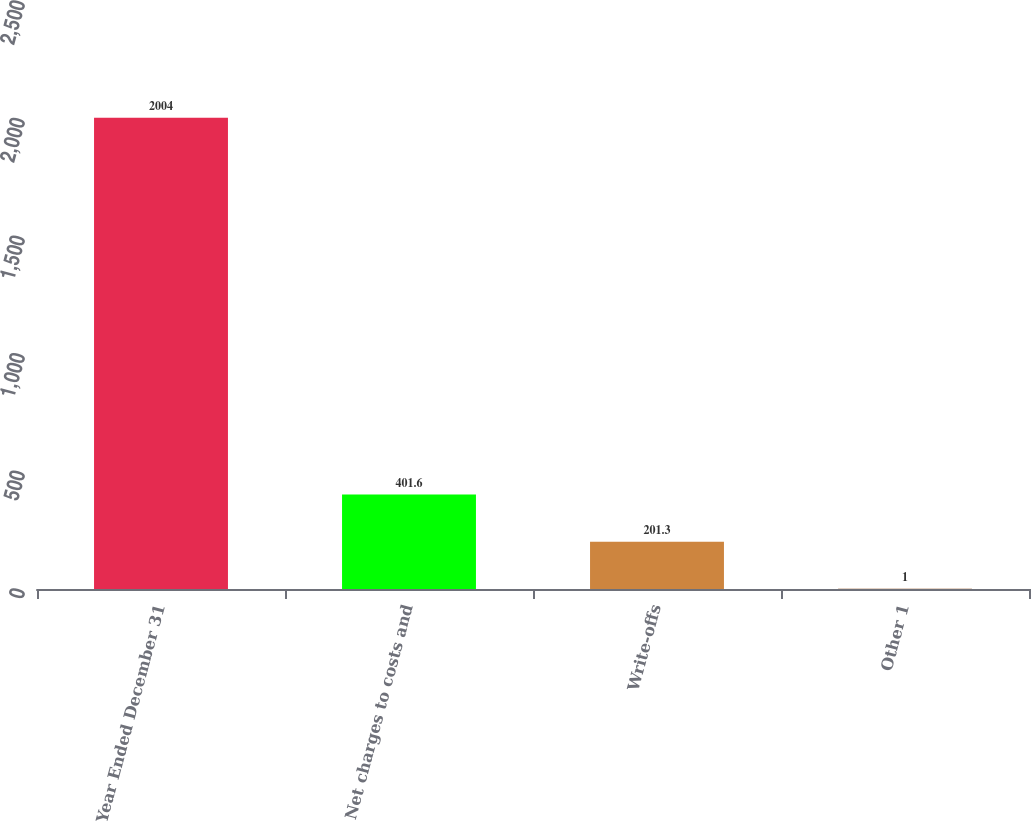Convert chart. <chart><loc_0><loc_0><loc_500><loc_500><bar_chart><fcel>Year Ended December 31<fcel>Net charges to costs and<fcel>Write-offs<fcel>Other 1<nl><fcel>2004<fcel>401.6<fcel>201.3<fcel>1<nl></chart> 